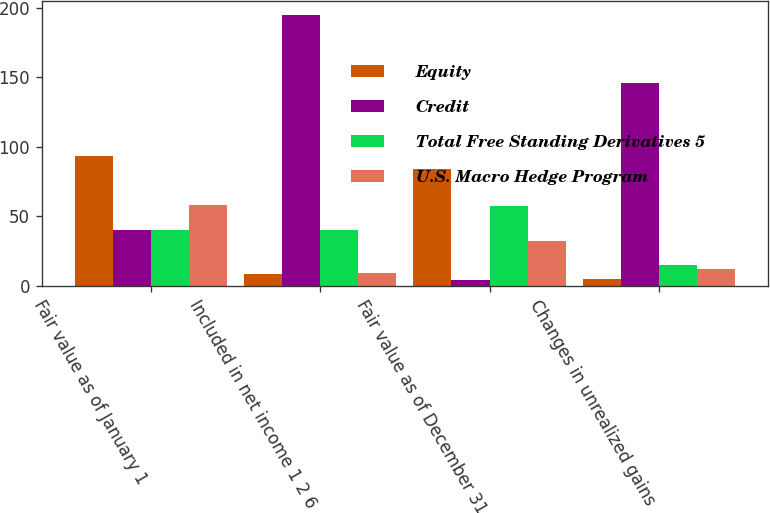<chart> <loc_0><loc_0><loc_500><loc_500><stacked_bar_chart><ecel><fcel>Fair value as of January 1<fcel>Included in net income 1 2 6<fcel>Fair value as of December 31<fcel>Changes in unrealized gains<nl><fcel>Equity<fcel>93<fcel>8<fcel>84<fcel>5<nl><fcel>Credit<fcel>40<fcel>195<fcel>4<fcel>146<nl><fcel>Total Free Standing Derivatives 5<fcel>40<fcel>40<fcel>57<fcel>15<nl><fcel>U.S. Macro Hedge Program<fcel>58<fcel>9<fcel>32<fcel>12<nl></chart> 